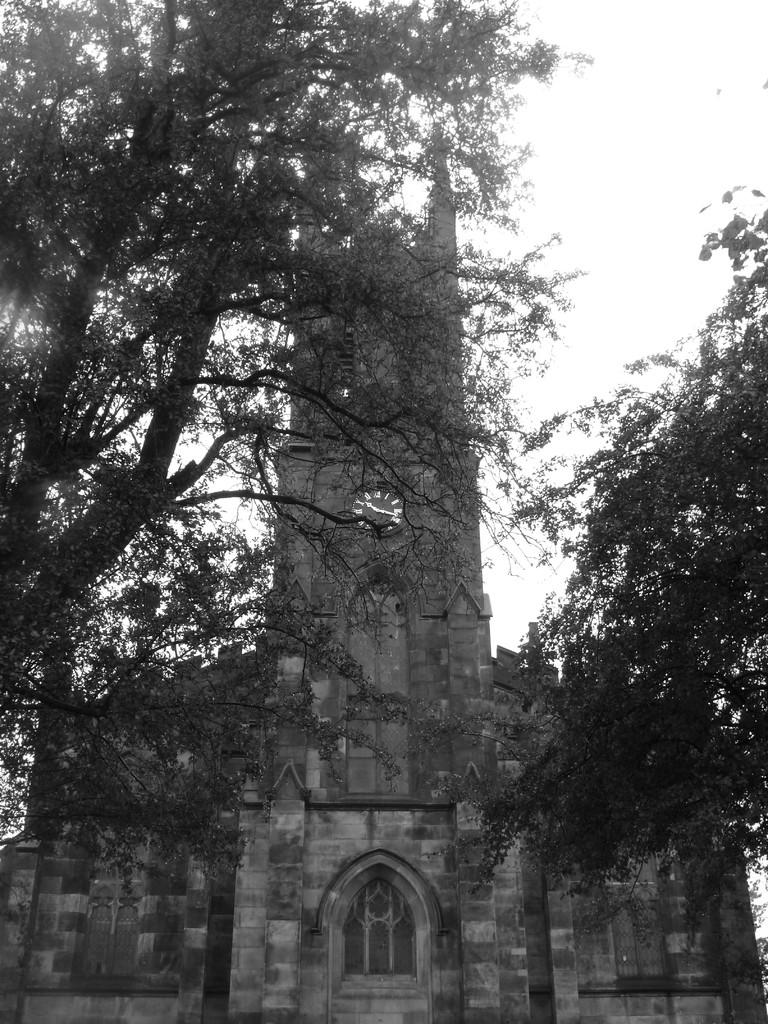What can be seen on the left side of the image? There is a tree on the left side of the image. What can be seen on the right side of the image? There is a tree on the right side of the image. What structure is located in the middle of the image? There is a building in the middle of the image. What is visible in the background of the image? The sky is visible in the background of the image. How many candles are on the birthday cake in the image? There is no birthday cake present in the image, so the number of candles cannot be determined. What type of chain is hanging from the tree in the image? There is no chain present in the image; only trees and a building are visible. 